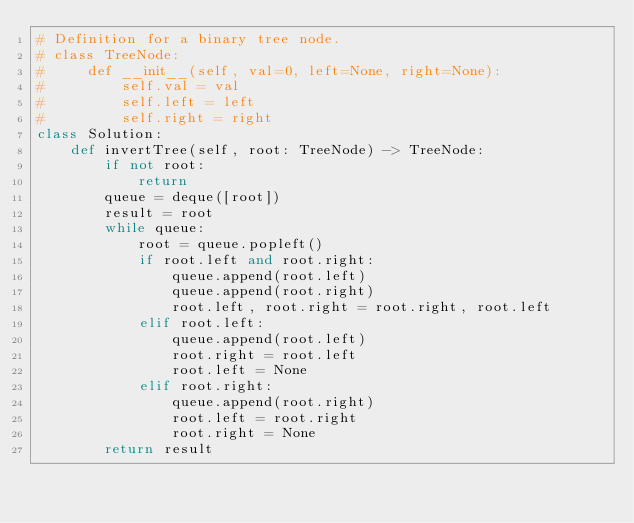<code> <loc_0><loc_0><loc_500><loc_500><_Python_># Definition for a binary tree node.
# class TreeNode:
#     def __init__(self, val=0, left=None, right=None):
#         self.val = val
#         self.left = left
#         self.right = right
class Solution:
    def invertTree(self, root: TreeNode) -> TreeNode:
        if not root:
            return 
        queue = deque([root])
        result = root 
        while queue:
            root = queue.popleft()
            if root.left and root.right:
                queue.append(root.left)
                queue.append(root.right)
                root.left, root.right = root.right, root.left
            elif root.left:
                queue.append(root.left)
                root.right = root.left
                root.left = None 
            elif root.right:
                queue.append(root.right)
                root.left = root.right
                root.right = None 
        return result</code> 